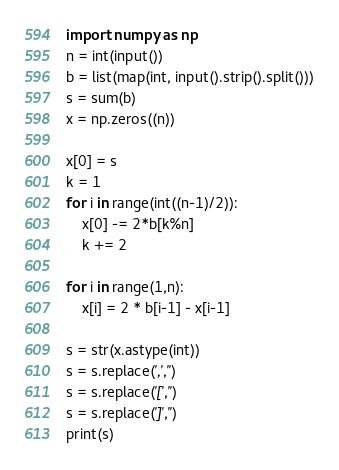Convert code to text. <code><loc_0><loc_0><loc_500><loc_500><_Python_>import numpy as np
n = int(input())
b = list(map(int, input().strip().split()))
s = sum(b)
x = np.zeros((n))

x[0] = s
k = 1
for i in range(int((n-1)/2)):
    x[0] -= 2*b[k%n]
    k += 2

for i in range(1,n):
    x[i] = 2 * b[i-1] - x[i-1]

s = str(x.astype(int))
s = s.replace(',','')
s = s.replace('[','')
s = s.replace(']','')
print(s)</code> 